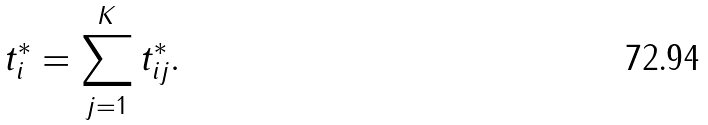<formula> <loc_0><loc_0><loc_500><loc_500>t ^ { * } _ { i } = \sum _ { j = 1 } ^ { K } t ^ { * } _ { i j } .</formula> 